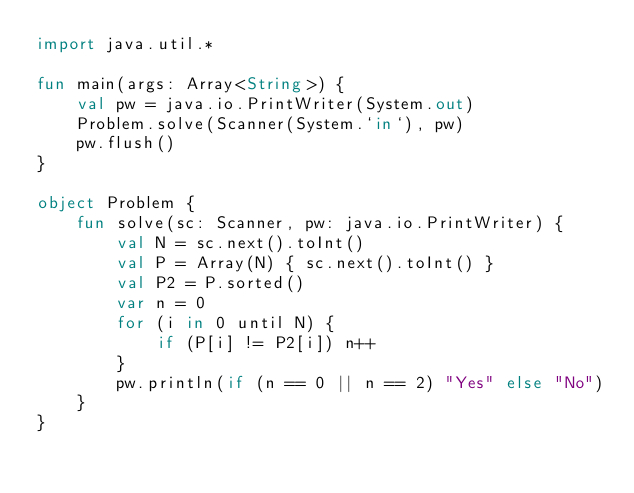<code> <loc_0><loc_0><loc_500><loc_500><_Kotlin_>import java.util.*

fun main(args: Array<String>) {
    val pw = java.io.PrintWriter(System.out)
    Problem.solve(Scanner(System.`in`), pw)
    pw.flush()
}

object Problem {
    fun solve(sc: Scanner, pw: java.io.PrintWriter) {
        val N = sc.next().toInt()
        val P = Array(N) { sc.next().toInt() }
        val P2 = P.sorted()
        var n = 0
        for (i in 0 until N) {
            if (P[i] != P2[i]) n++
        }
        pw.println(if (n == 0 || n == 2) "Yes" else "No")
    }
}
</code> 